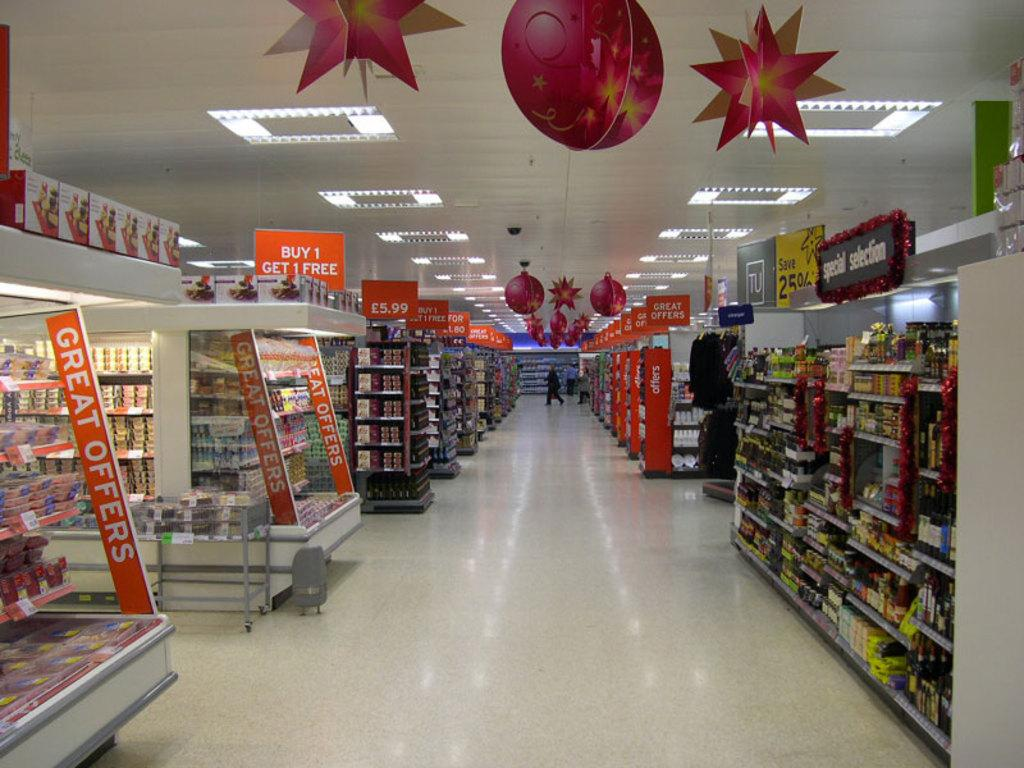<image>
Summarize the visual content of the image. An aisle in a supermarket with orange banners that say "Great Offers". 